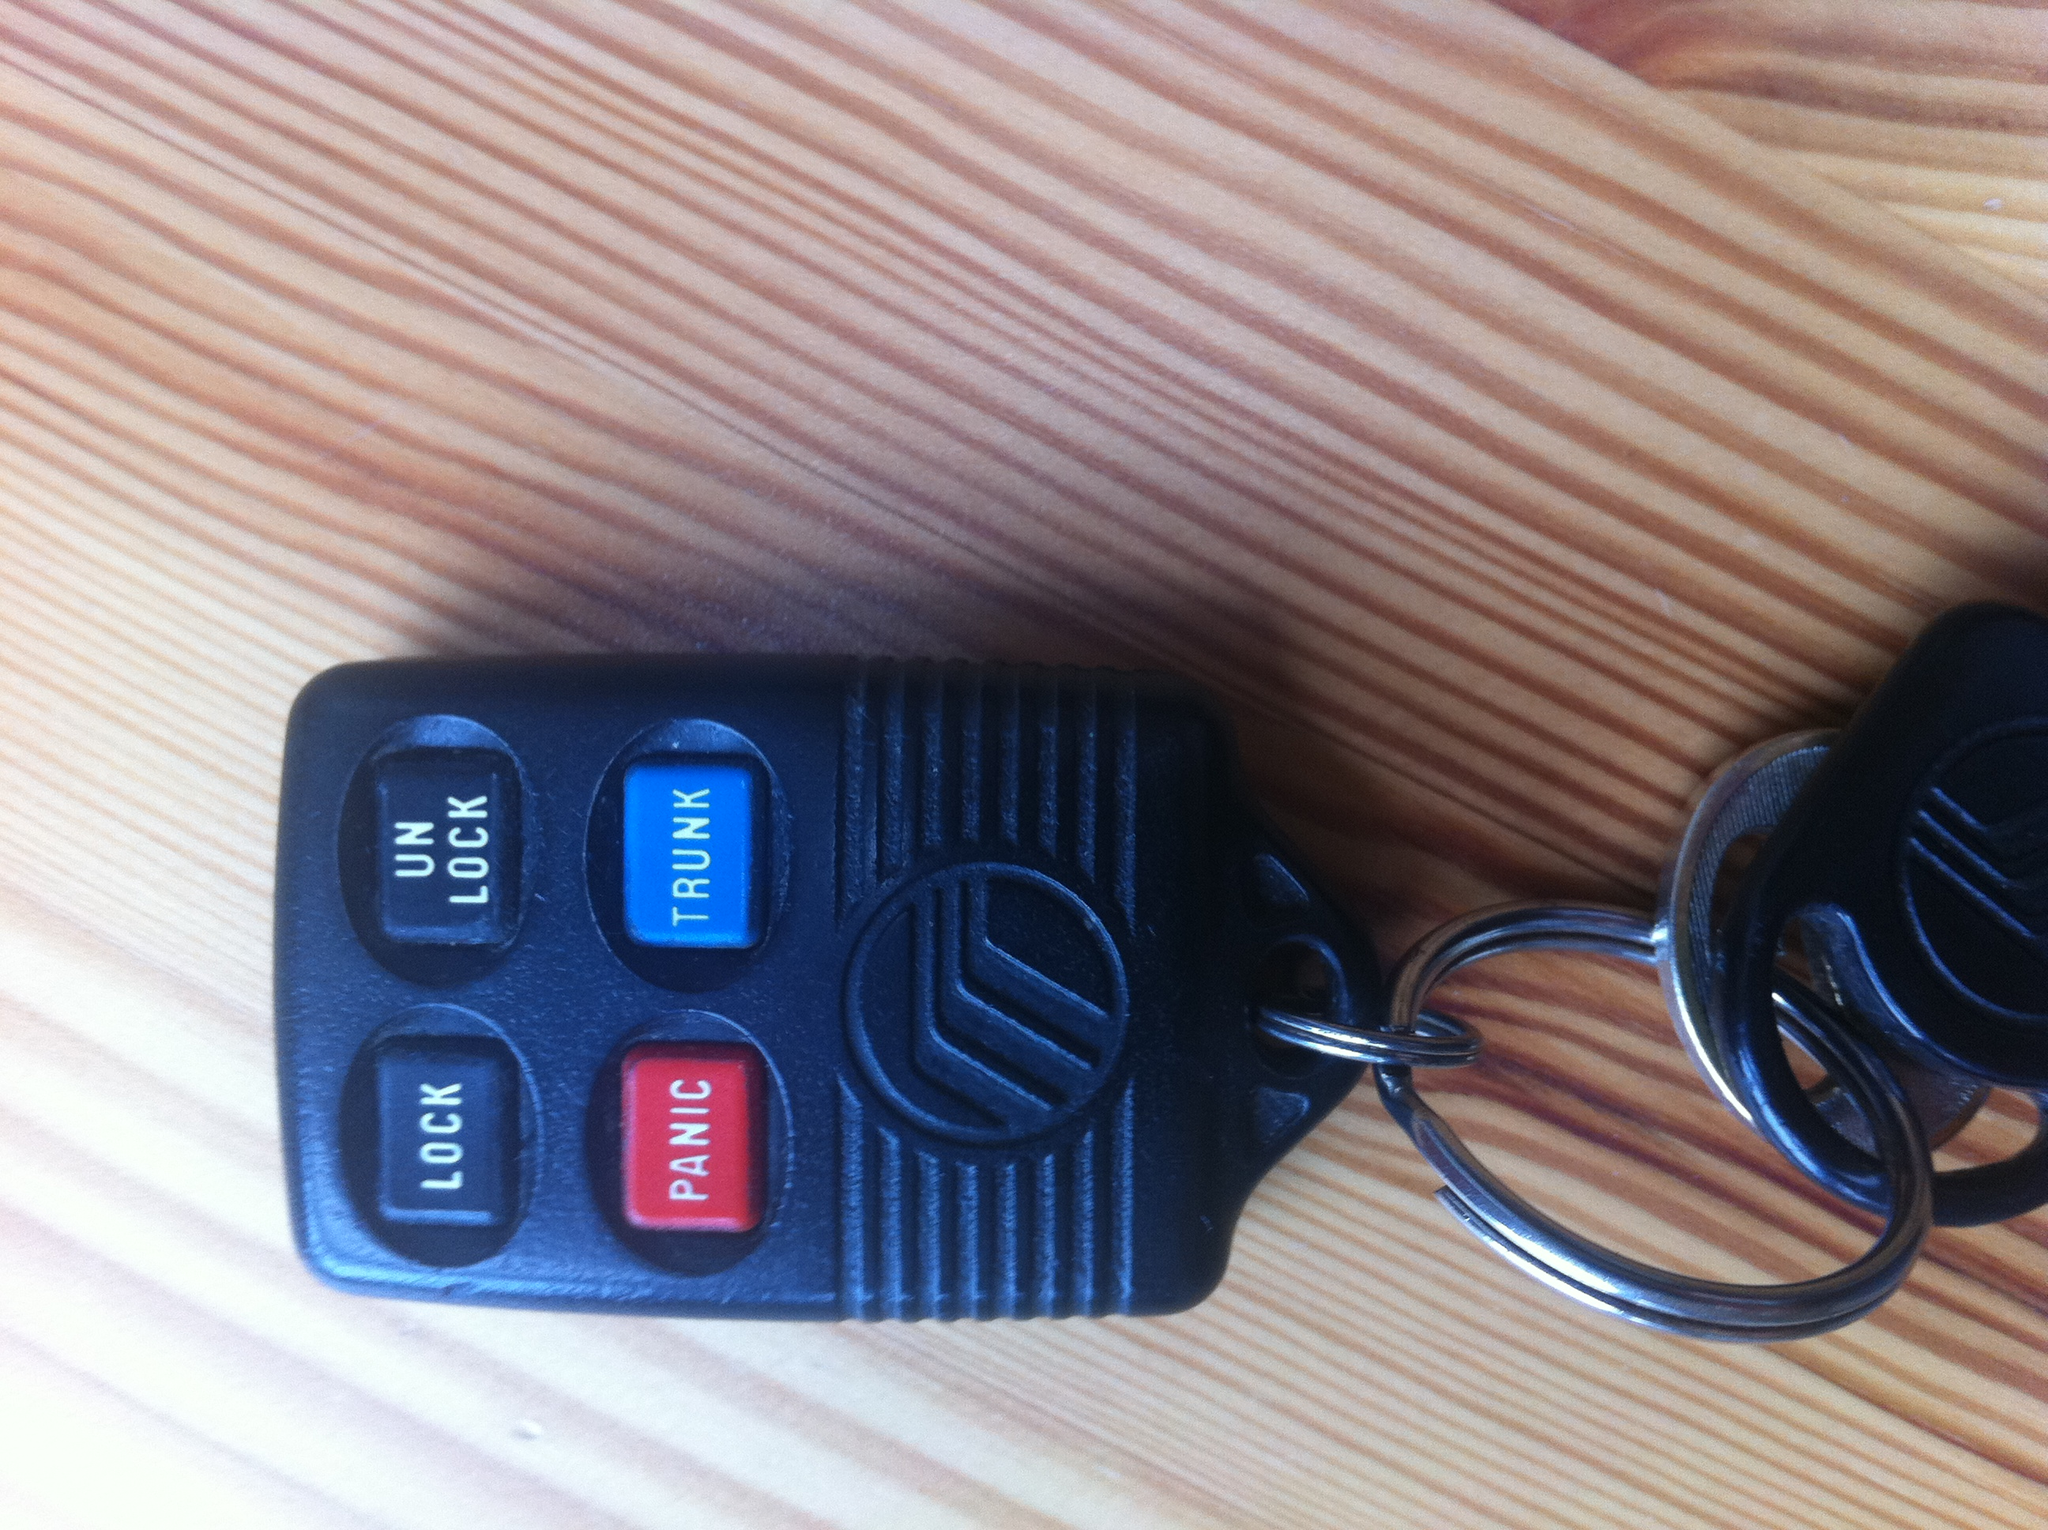What is the primary purpose of these keys? The primary purpose of these keys is to remotely control the locking and unlocking of a vehicle, as well as opening the trunk and activating a panic alarm. 